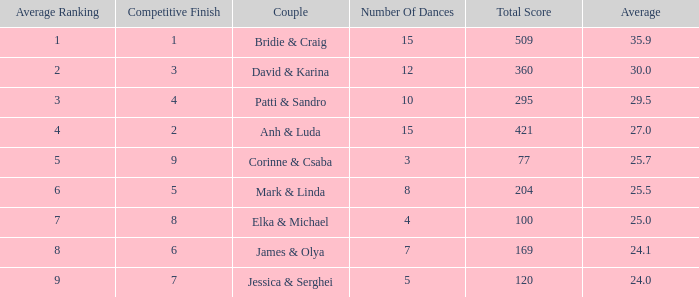What is the cumulative score when 7 is the mean rating? 100.0. 